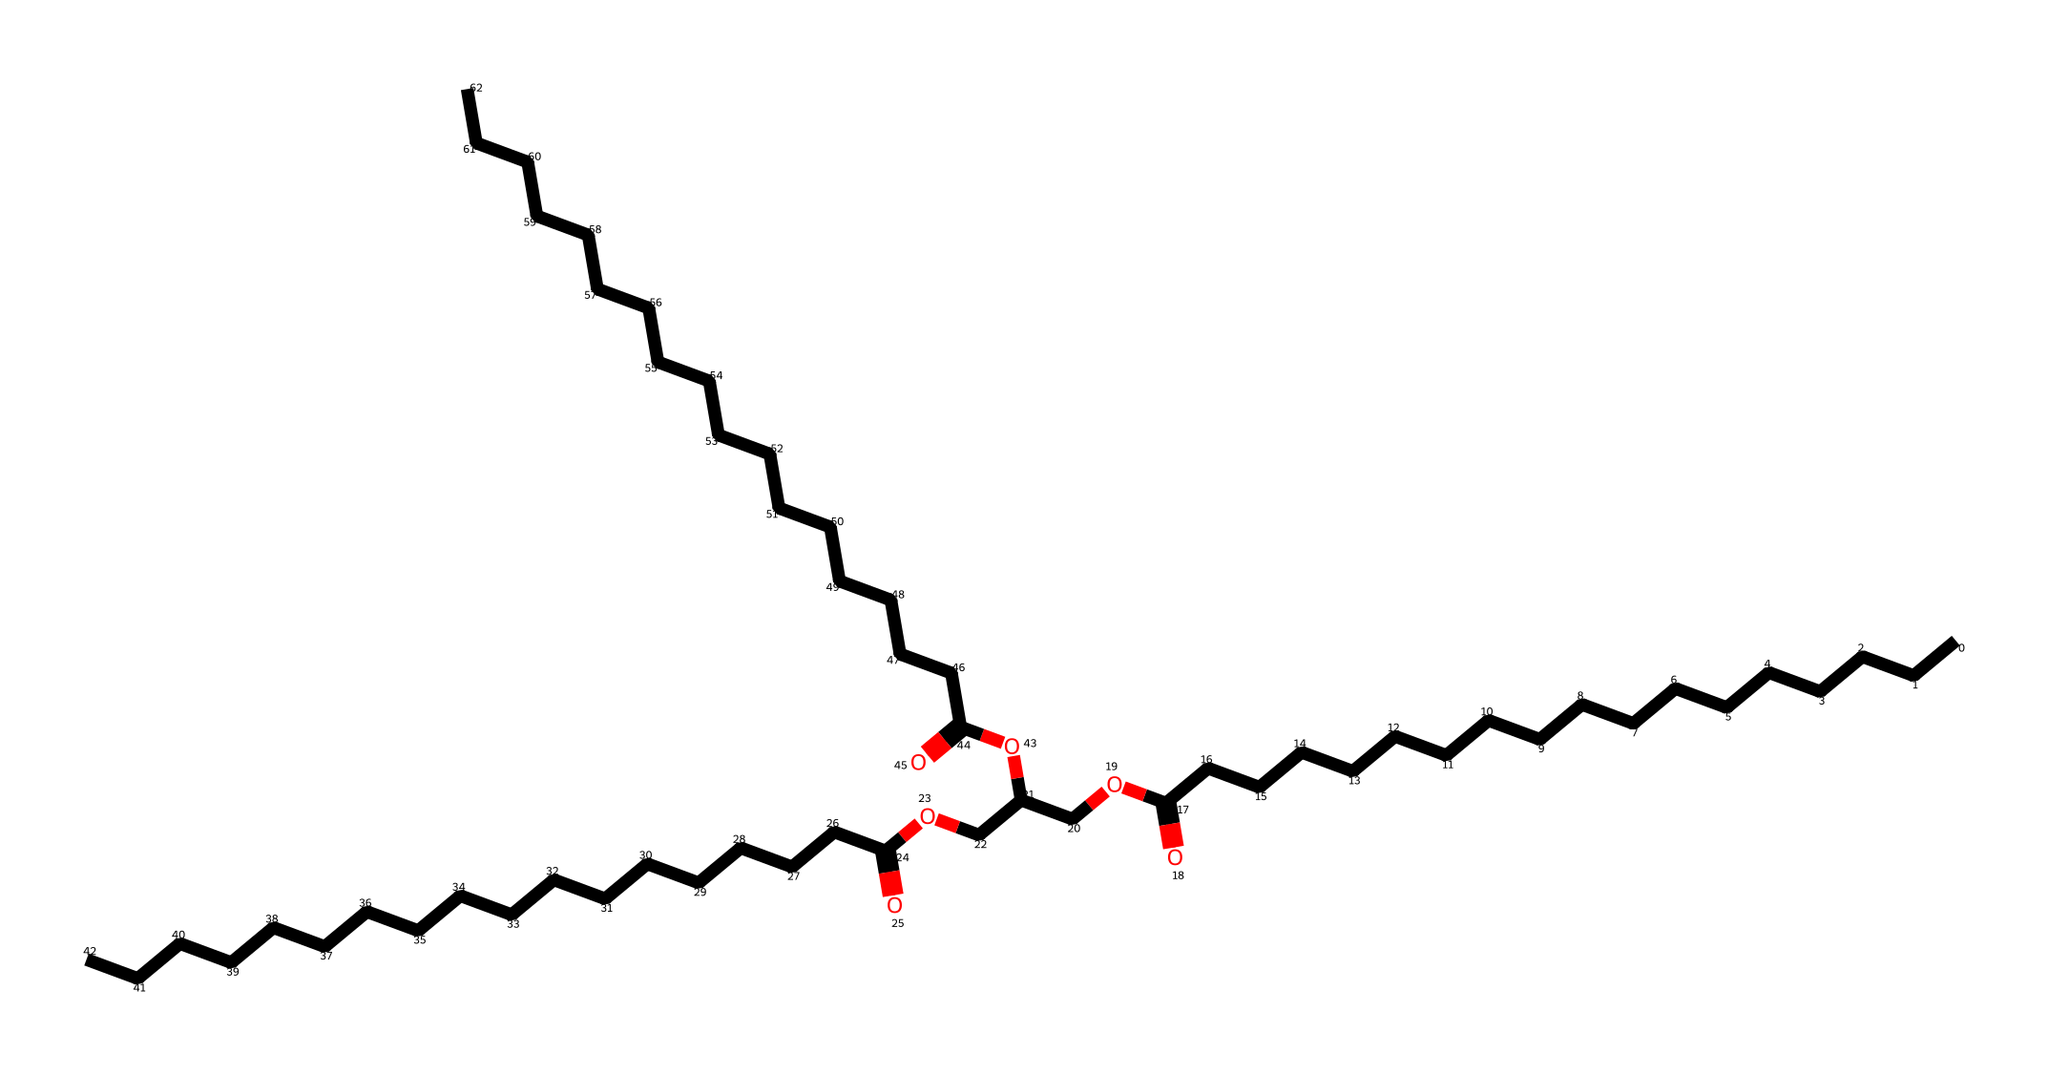how many carbon atoms are present in the molecule? By examining the SMILES representation, we can count the number of 'C' characters. Each 'C' represents a carbon atom. There are 36 'C' characters in the provided SMILES, indicating there are 36 carbon atoms in the molecule.
Answer: 36 what is the functional group present in this compound? The compound features a carboxylic acid group (–COOH), which is identifiable by the presence of the '(=O)O' portion in the SMILES. This indicates that there is a carbon that is double-bonded to an oxygen and single-bonded to a hydroxyl group.
Answer: carboxylic acid how many ester groups are found in this biodiesel structure? Within the SMILES representation, we can see the sections that have the structure 'COOC', which indicates an ester functional group. By identifying the segments of the molecule that contain this pattern, we can count three occurrences, indicating there are three ester groups in total.
Answer: 3 which type of molecule does this structure represent? This structure is indicative of a lipid or fatty acid methyl ester, commonly found in biodiesel. The long carbon chain and presence of ester groups point toward its classification within the lipid family.
Answer: lipid is this compound likely to be soluble in water? Considering the presence of long hydrocarbon chains (36 carbon atoms) in conjunction with only a few functional groups (like the carboxylic acid), we can infer that the hydrophobic characteristics dominate. Such large hydrocarbon chains typically make the compound insoluble in water.
Answer: no what is the primary source of this biodiesel? Based on the structure which indicates long-chain fatty acids, biodiesel typically derives from vegetable oils or animal fats, as they contain similar fatty acid esters.
Answer: vegetable oils or animal fats 